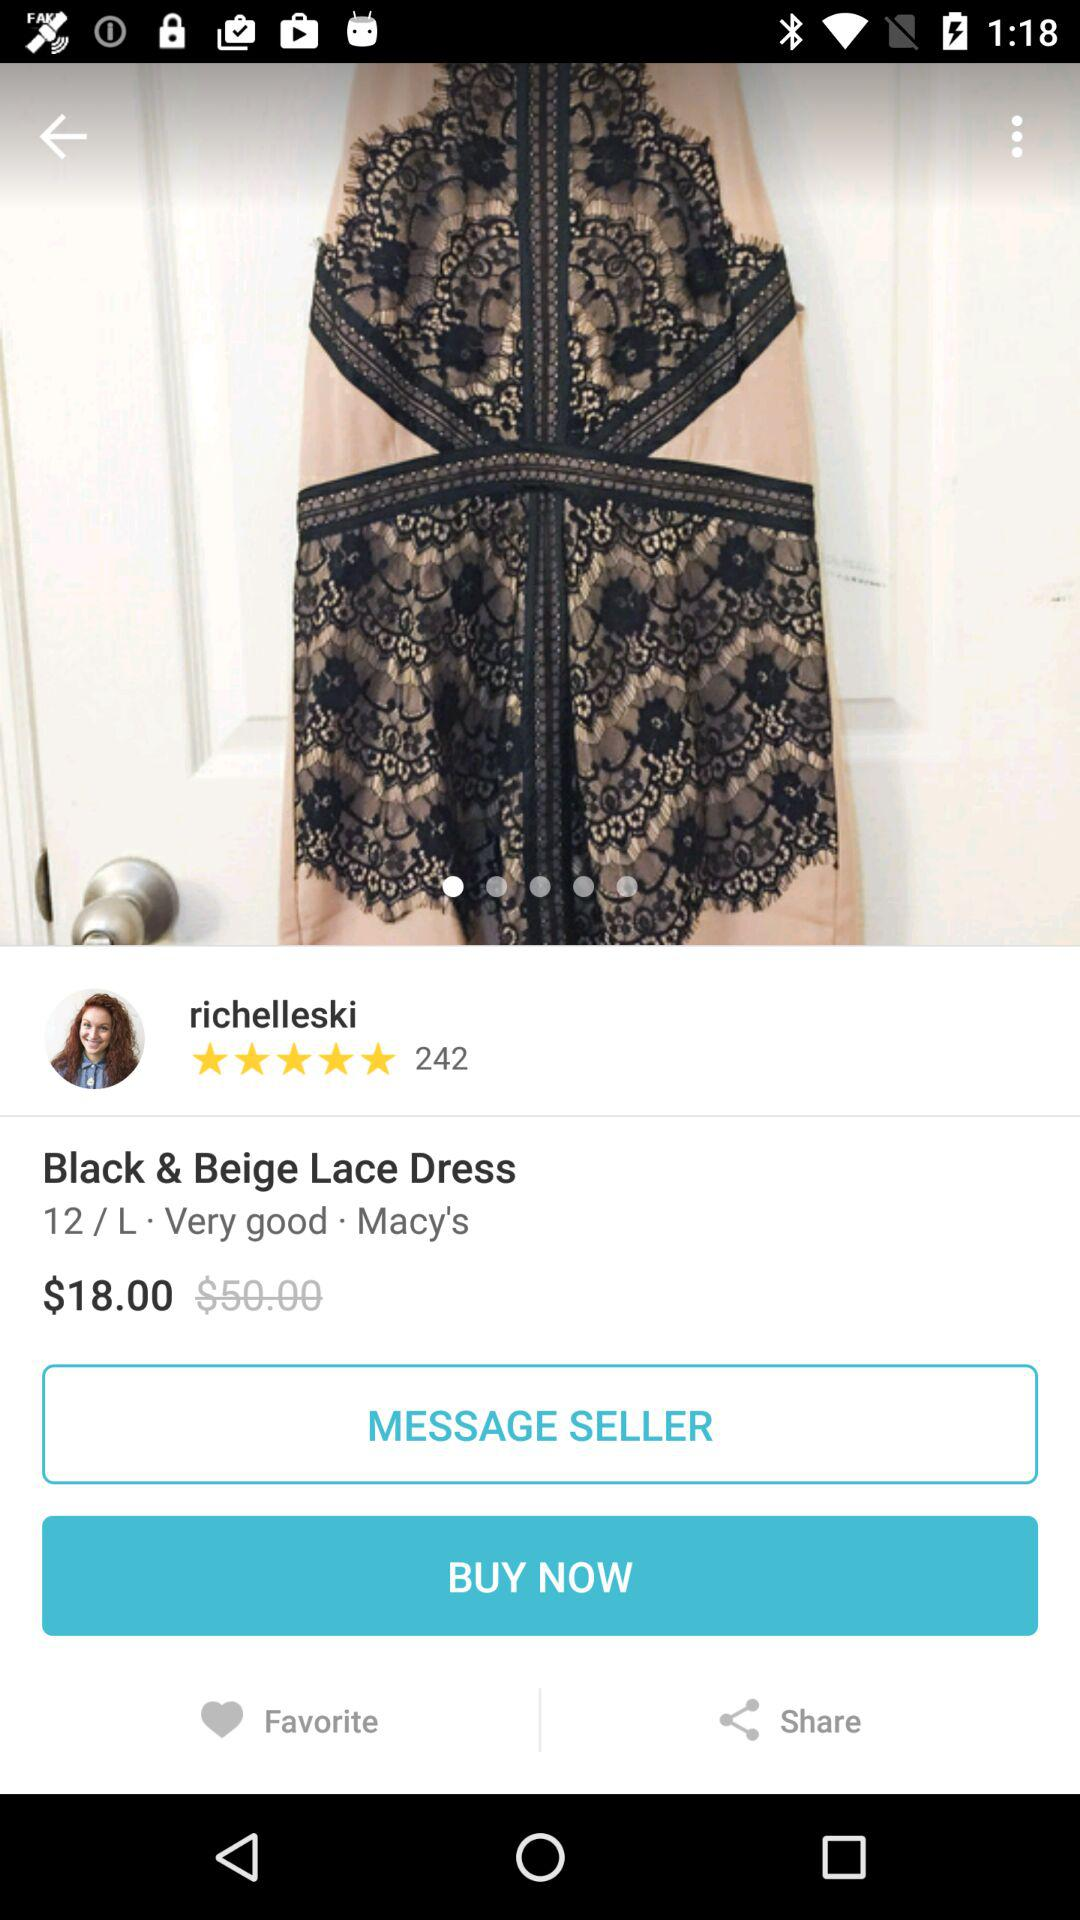How much more does the dress cost than the seller's asking price?
Answer the question using a single word or phrase. $32.00 